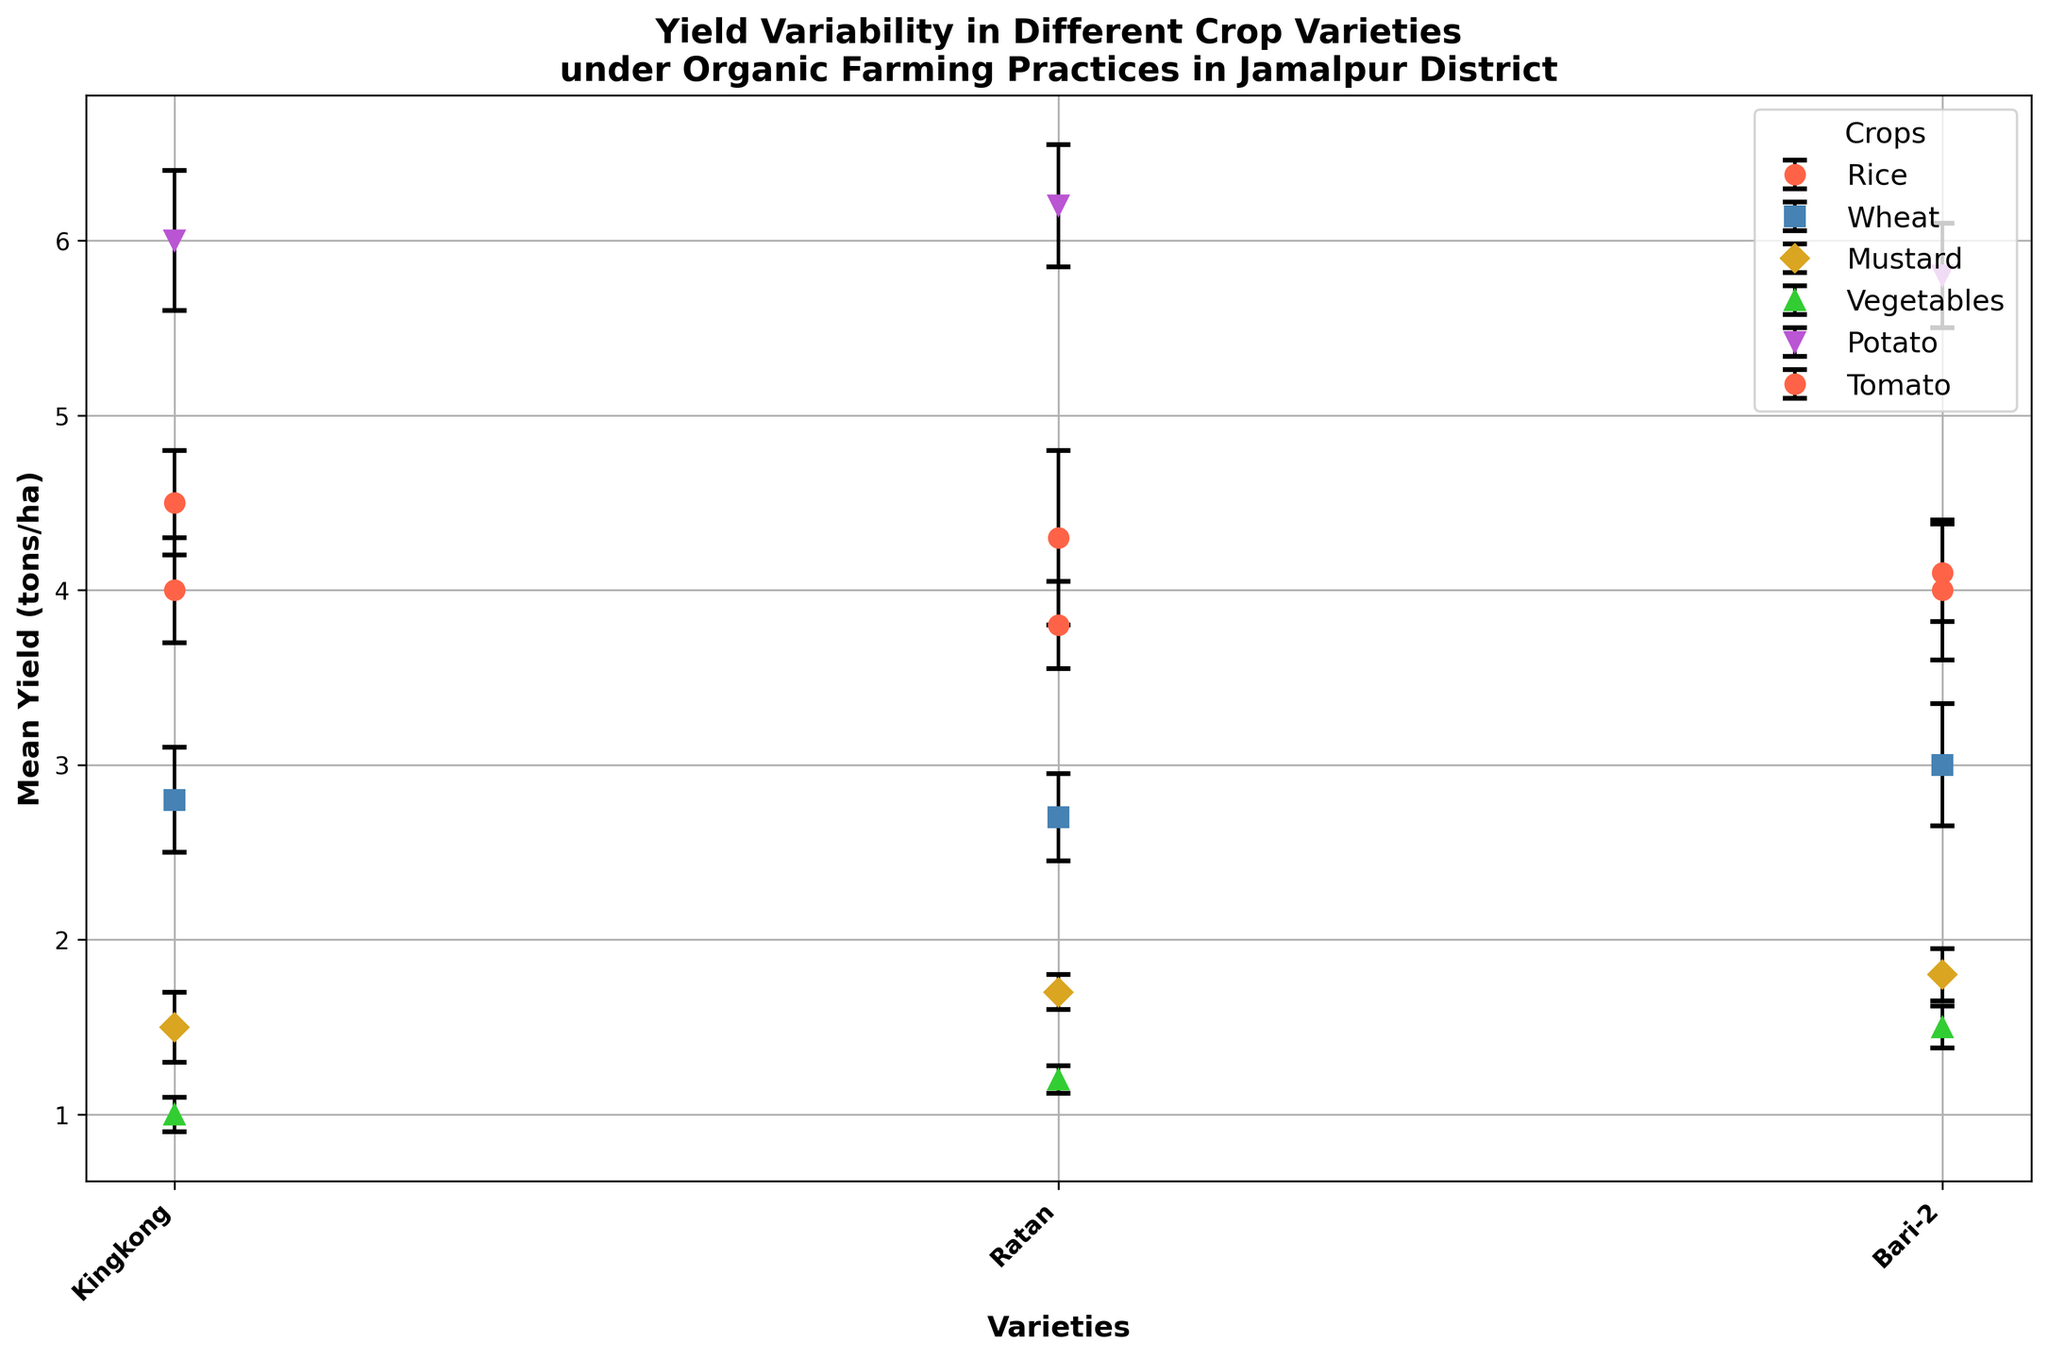what is the crop variety with the highest mean yield? To determine the crop variety with the highest mean yield, look at the y-axis values of each crop variety in the figure. The variety with the tallest point on the y-axis represents the highest mean yield.
Answer: Asterix (Potato) Which crop has the lowest mean yield among its varieties? To determine which crop has the lowest mean yield, look at the y-axis values of all the crop varieties and find the variety with the lowest point on the y-axis. Then, identify the crop to which this variety belongs.
Answer: Lalshak (Amaranth) How does the mean yield of BRRI Dhan29 (Rice) compare to that of Granola (Potato)? To compare the mean yields, find the points representing BRRI Dhan29 (Rice) and Granola (Potato). Look at their positions on the y-axis and compare their heights.
Answer: The mean yield of BRRI Dhan29 (Rice) is lower than that of Granola (Potato) What is the mean yield range of Mustard varieties? To find the range, identify the Mustard varieties and note their highest and lowest mean yields. Subtract the lowest mean yield from the highest mean yield.
Answer: 1.8 - 1.5 = 0.3 tons/ha Which crop has the most consistent (lowest variability) mean yield among its varieties? To determine the most consistent mean yield, look for the smallest error bars (standard deviations) among the varieties of each crop. Then compare these error bars to determine which crop has the smallest overall variability.
Answer: Mustard-7 (Mustard) What is the average mean yield of all Rice varieties? To find the average mean yield of Rice varieties, sum the mean yields of all Rice varieties and divide by the number of varieties. (4.5 + 4.3 + 4.0) / 3
Answer: (4.5 + 4.3 + 4.0) / 3 ≈ 4.27 tons/ha Which crop variety shows the largest error bar (highest variability)? To find the variety with the largest error bar, visually compare the lengths of the error bars for all crop varieties and identify the longest one.
Answer: BRRI Dhan50 (Rice) Compare the mean yield of Tomato varieties to that of Mustard varieties. Which group has a higher overall mean yield? To compare the groups, find the mean yields of the Tomato varieties and the Mustard varieties. Sum each group's mean yields and divide by the number of varieties in each group. Compare the two results.
Answer: Tomato varieties have a higher overall mean yield Is there a crop variety whose mean yield and error bar fall entirely within another crop's error bar? To answer this, visually check if the entire range (mean yield ± error bar) of any crop variety is within the error bar range of another variety's mean yield.
Answer: No, there is no such crop variety 